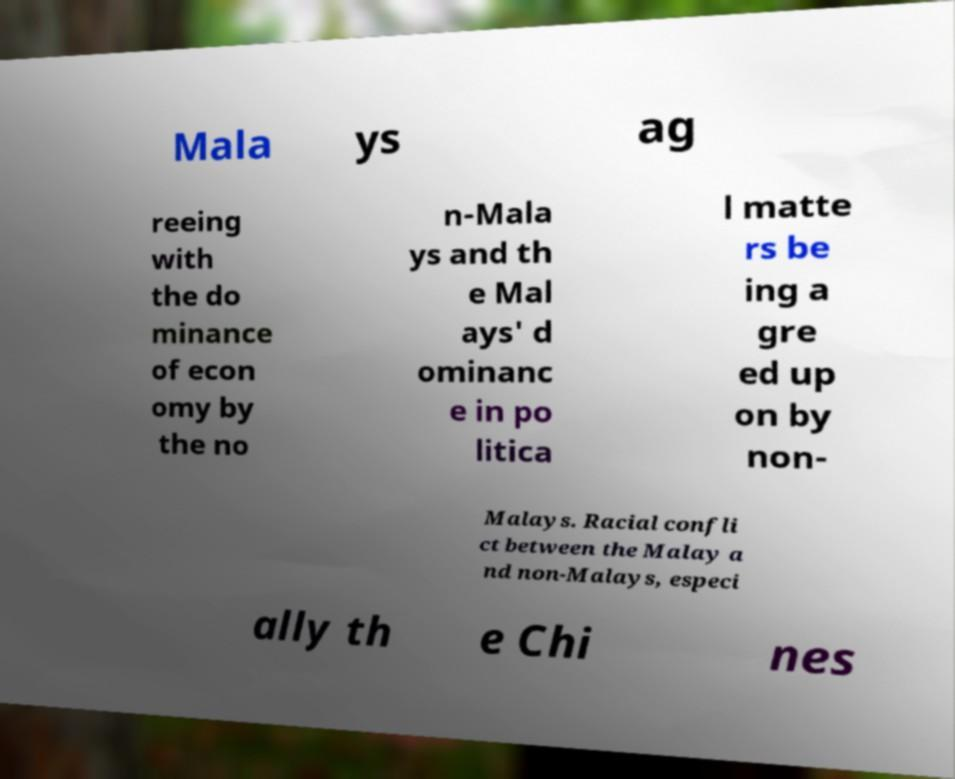Could you assist in decoding the text presented in this image and type it out clearly? Mala ys ag reeing with the do minance of econ omy by the no n-Mala ys and th e Mal ays' d ominanc e in po litica l matte rs be ing a gre ed up on by non- Malays. Racial confli ct between the Malay a nd non-Malays, especi ally th e Chi nes 